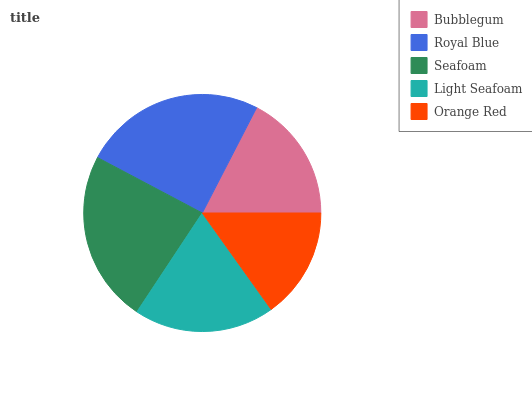Is Orange Red the minimum?
Answer yes or no. Yes. Is Royal Blue the maximum?
Answer yes or no. Yes. Is Seafoam the minimum?
Answer yes or no. No. Is Seafoam the maximum?
Answer yes or no. No. Is Royal Blue greater than Seafoam?
Answer yes or no. Yes. Is Seafoam less than Royal Blue?
Answer yes or no. Yes. Is Seafoam greater than Royal Blue?
Answer yes or no. No. Is Royal Blue less than Seafoam?
Answer yes or no. No. Is Light Seafoam the high median?
Answer yes or no. Yes. Is Light Seafoam the low median?
Answer yes or no. Yes. Is Bubblegum the high median?
Answer yes or no. No. Is Royal Blue the low median?
Answer yes or no. No. 